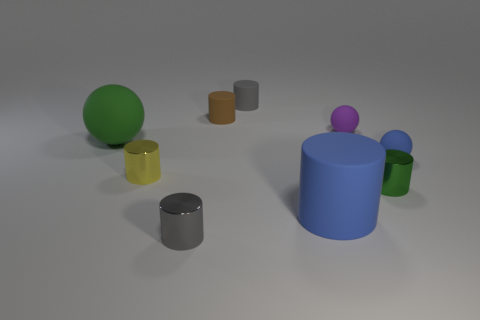Subtract all brown cylinders. How many cylinders are left? 5 Subtract all big cylinders. How many cylinders are left? 5 Add 1 blue balls. How many objects exist? 10 Subtract all red cylinders. Subtract all yellow balls. How many cylinders are left? 6 Subtract all balls. How many objects are left? 6 Add 8 big blue objects. How many big blue objects are left? 9 Add 2 cyan cylinders. How many cyan cylinders exist? 2 Subtract 0 cyan cylinders. How many objects are left? 9 Subtract all brown matte objects. Subtract all small green shiny cylinders. How many objects are left? 7 